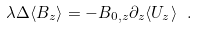<formula> <loc_0><loc_0><loc_500><loc_500>\lambda \Delta \langle B _ { z } \rangle = - B _ { 0 , z } \partial _ { z } \langle U _ { z } \rangle \ .</formula> 